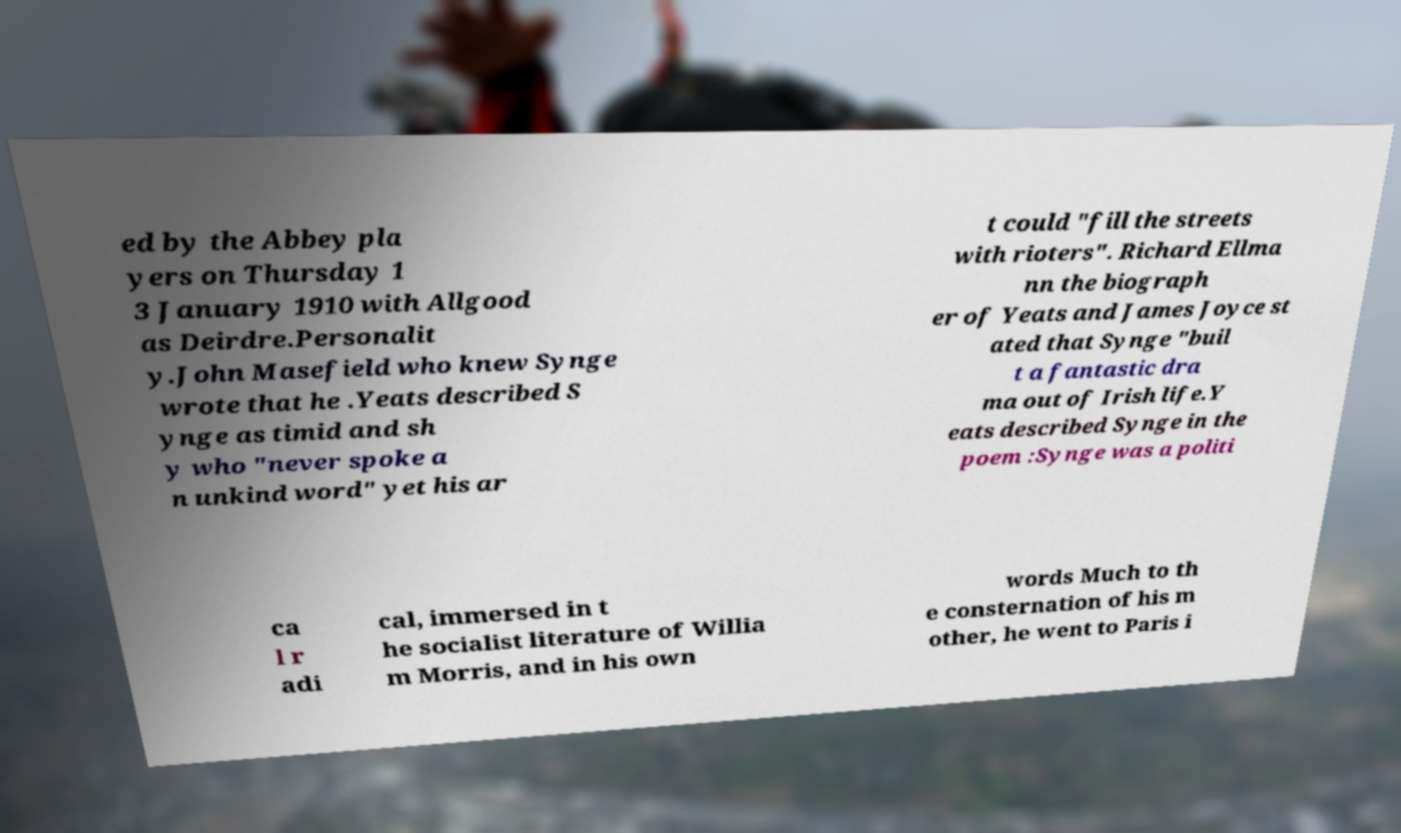Please read and relay the text visible in this image. What does it say? ed by the Abbey pla yers on Thursday 1 3 January 1910 with Allgood as Deirdre.Personalit y.John Masefield who knew Synge wrote that he .Yeats described S ynge as timid and sh y who "never spoke a n unkind word" yet his ar t could "fill the streets with rioters". Richard Ellma nn the biograph er of Yeats and James Joyce st ated that Synge "buil t a fantastic dra ma out of Irish life.Y eats described Synge in the poem :Synge was a politi ca l r adi cal, immersed in t he socialist literature of Willia m Morris, and in his own words Much to th e consternation of his m other, he went to Paris i 